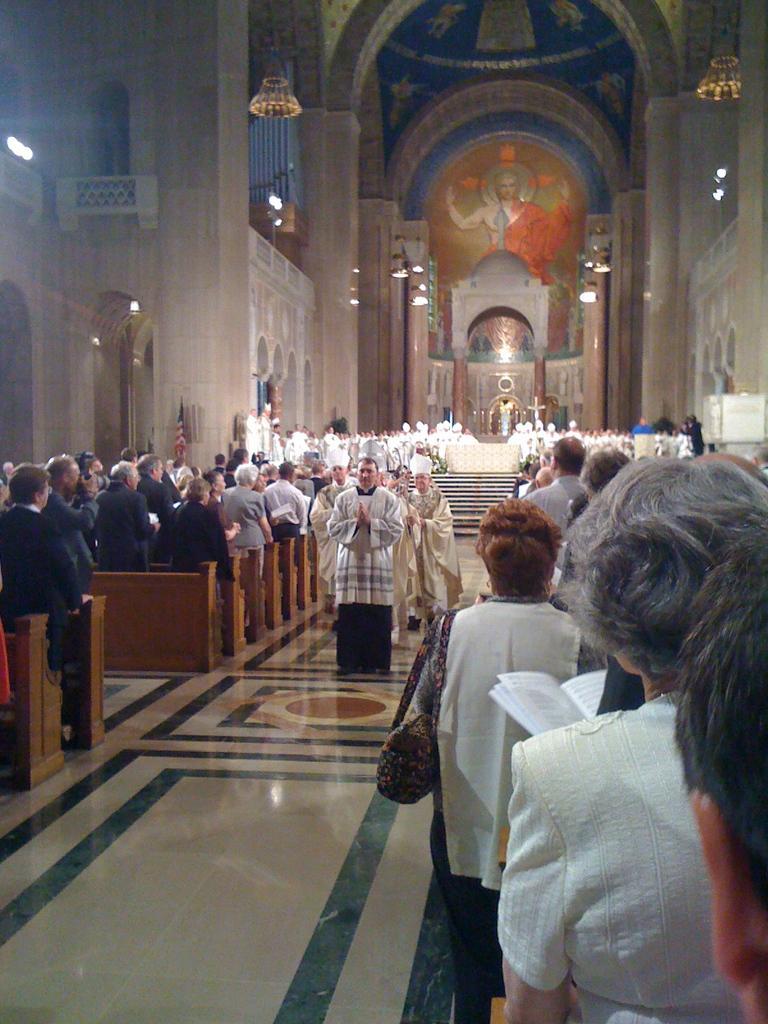Please provide a concise description of this image. In this image I see the inside of a building and I see number of people who are standing and I see the floor. In the background I see the wall and I see an art over here and I see the lights. 